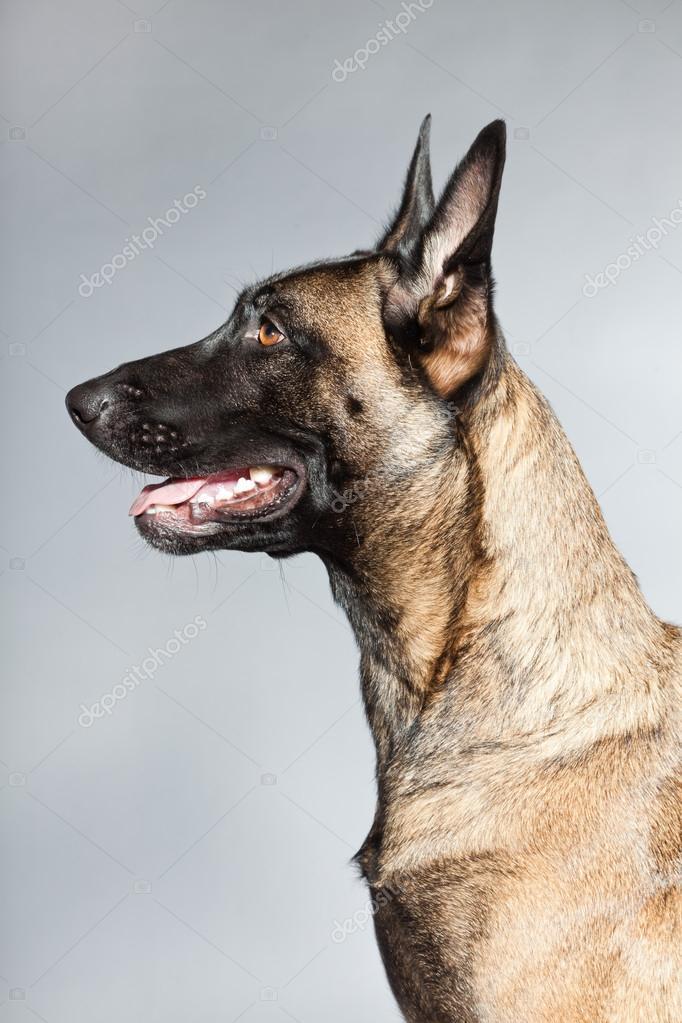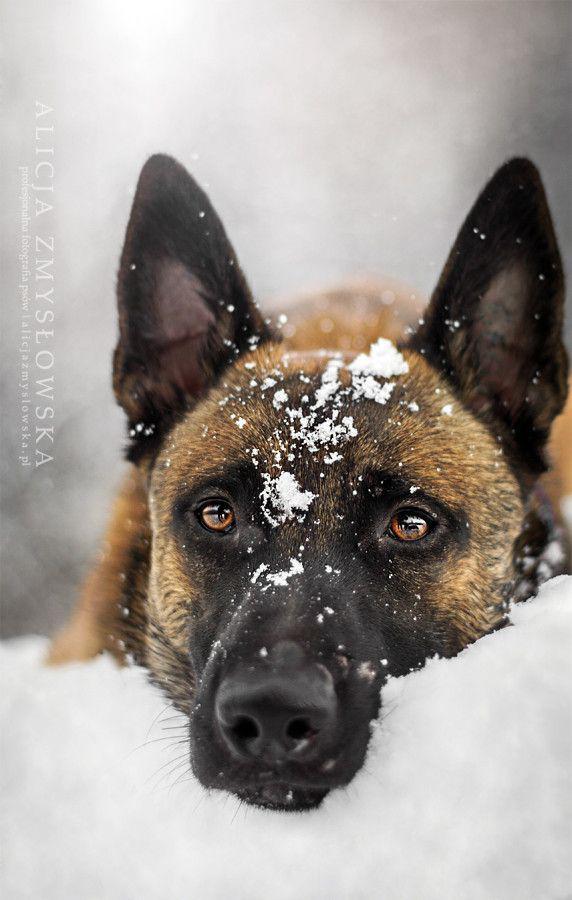The first image is the image on the left, the second image is the image on the right. For the images displayed, is the sentence "An image shows one german shepherd dog with a dusting of snow on the fur of its face." factually correct? Answer yes or no. Yes. 